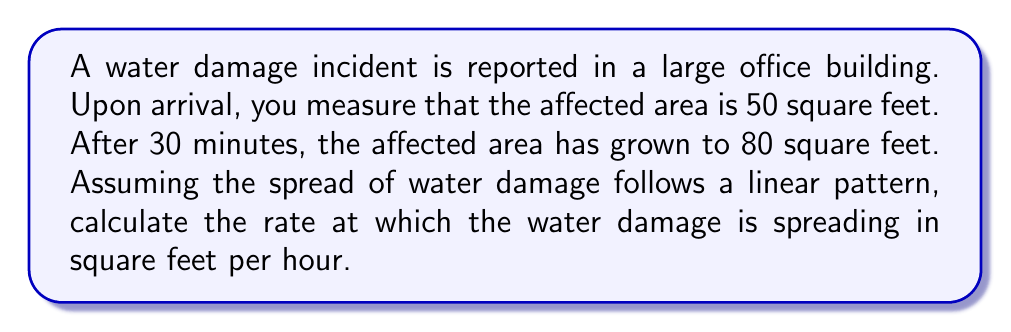Help me with this question. To solve this problem, we'll use a linear equation to model the spread of water damage over time. Let's follow these steps:

1. Define variables:
   Let $x$ = time in hours
   Let $y$ = affected area in square feet

2. Identify two points from the given information:
   Point 1: $(0, 50)$ - At the start (0 hours), the affected area is 50 sq ft
   Point 2: $(0.5, 80)$ - After 30 minutes (0.5 hours), the affected area is 80 sq ft

3. Use the point-slope form of a linear equation:
   $y - y_1 = m(x - x_1)$
   Where $m$ is the slope (rate of change) we're looking for

4. Calculate the slope using the two points:
   $m = \frac{y_2 - y_1}{x_2 - x_1} = \frac{80 - 50}{0.5 - 0} = \frac{30}{0.5} = 60$

5. The slope, 60, represents the rate of change in square feet per hour

Therefore, the water damage is spreading at a rate of 60 square feet per hour.
Answer: 60 sq ft/hr 